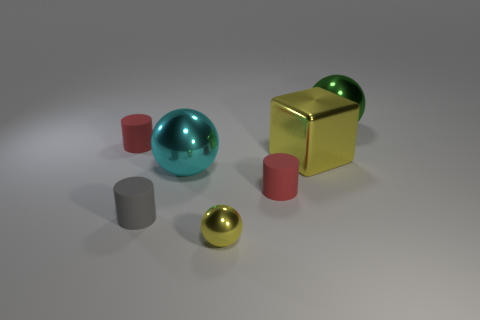There is a cube that is the same color as the tiny sphere; what material is it?
Provide a short and direct response. Metal. The metal object that is the same color as the big cube is what shape?
Provide a short and direct response. Sphere. There is a red thing right of the gray cylinder; how many big shiny things are left of it?
Provide a short and direct response. 1. Is the number of large green balls that are to the left of the green metal sphere less than the number of things on the right side of the gray matte cylinder?
Provide a short and direct response. Yes. What is the shape of the yellow object behind the big ball in front of the big green metallic object?
Your answer should be compact. Cube. How many other things are there of the same material as the yellow cube?
Give a very brief answer. 3. Is there any other thing that has the same size as the gray cylinder?
Ensure brevity in your answer.  Yes. Is the number of yellow spheres greater than the number of large balls?
Give a very brief answer. No. There is a red matte thing that is on the left side of the small yellow metal sphere that is to the right of the cylinder that is behind the large cyan object; what size is it?
Your answer should be very brief. Small. Does the yellow sphere have the same size as the red object to the left of the yellow sphere?
Offer a terse response. Yes. 